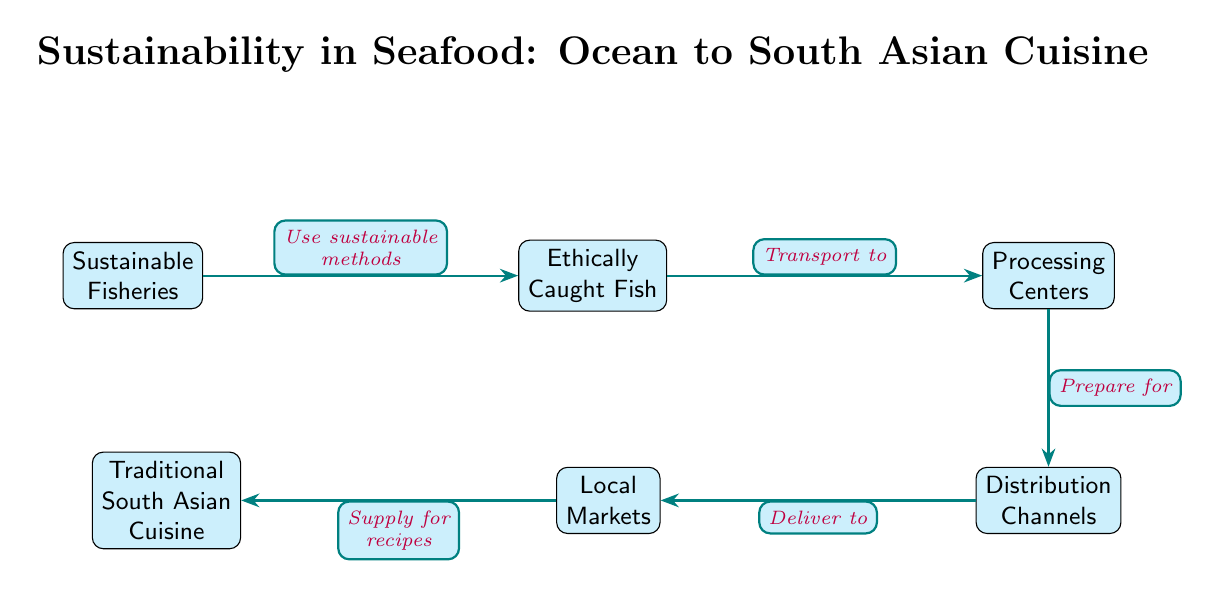What is the first node in the diagram? The first node in the diagram represents the starting point of the food chain and is labeled "Sustainable Fisheries." This indicates the initial step in the pathway of seafood sustainability.
Answer: Sustainable Fisheries How many nodes are there in the diagram? To determine the number of nodes, we can count each distinct step in the food chain, which includes Sustainable Fisheries, Ethically Caught Fish, Processing Centers, Distribution Channels, Local Markets, and Traditional South Asian Cuisine. This results in a total of six nodes present in the diagram.
Answer: 6 What does the edge from "Caught Fish" to "Processing Centers" indicate? The edge from "Caught Fish" to "Processing Centers" represents the transportation step where ethically caught fish are transported to processing centers. This establishes a link in the supply chain for seafood, showing the transition from raw fish to processed goods.
Answer: Transport to Which node supplies for recipes? The node that supplies for recipes is identified as "Traditional South Asian Cuisine," showing the connection between local markets and the culinary practices that integrate seafood into traditional dishes.
Answer: Traditional South Asian Cuisine What is the relationship between "Processing Centers" and "Distribution Channels"? The arrow connecting "Processing Centers" to "Distribution Channels" indicates that the processed seafood is prepared for distribution to various markets. This step emphasizes the importance of distribution after processing to ensure seafood reaches consumers.
Answer: Prepare for What are the direct sources for "Traditional South Asian Cuisine"? The direct sources for "Traditional South Asian Cuisine" are the "Local Markets," which receive their supply from the distribution channels that handle the delivered fish. This relationship highlights the essential role of local markets in traditional cooking practices.
Answer: Local Markets How does sustainability in seafood ultimately benefit cuisine? Sustainability in seafood benefits cuisine by ensuring that the sources of fish are ethically and sustainably caught and processed, which leads to healthier ecosystems and communities, thus enriching the quality of traditional dishes in South Asian cuisine.
Answer: Enriches quality What process is involved between the "Ethically Caught Fish" and "Processing Centers"? The process involved is the transport of the ethically caught fish to the processing centers. This denotes a crucial step in the seafood supply chain where the raw material is moved for further preparation and handling.
Answer: Transport to 